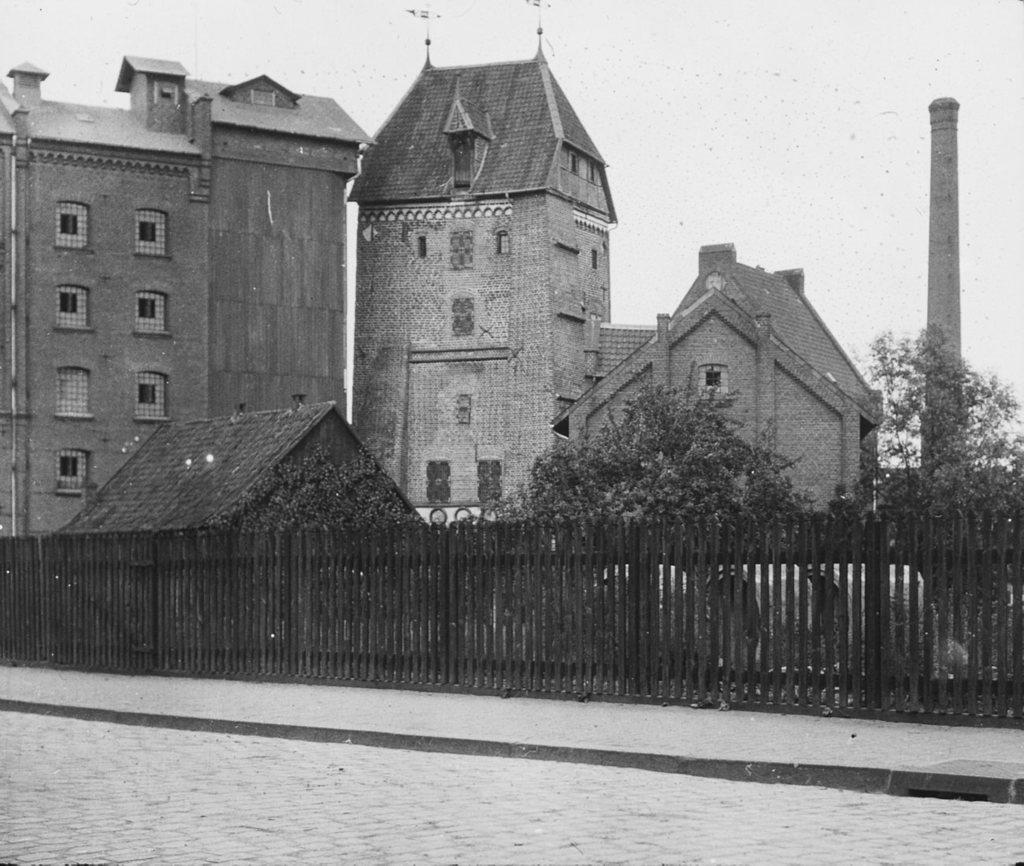What is the color scheme of the image? The image is black and white. What can be seen at the bottom of the image? There is a road at the bottom of the image. What is located beside the road? There is a picket fence beside the road. What type of structures are present in the image? There are buildings in the image. What other natural elements can be seen in the image? There are trees in the image. What is the prominent feature on the right side of the image? There is a monument on the right side of the image. How many spiders are crawling on the monument in the image? There are no spiders present in the image; it only features a monument. What type of surprise can be seen in the image? There is no surprise depicted in the image. 